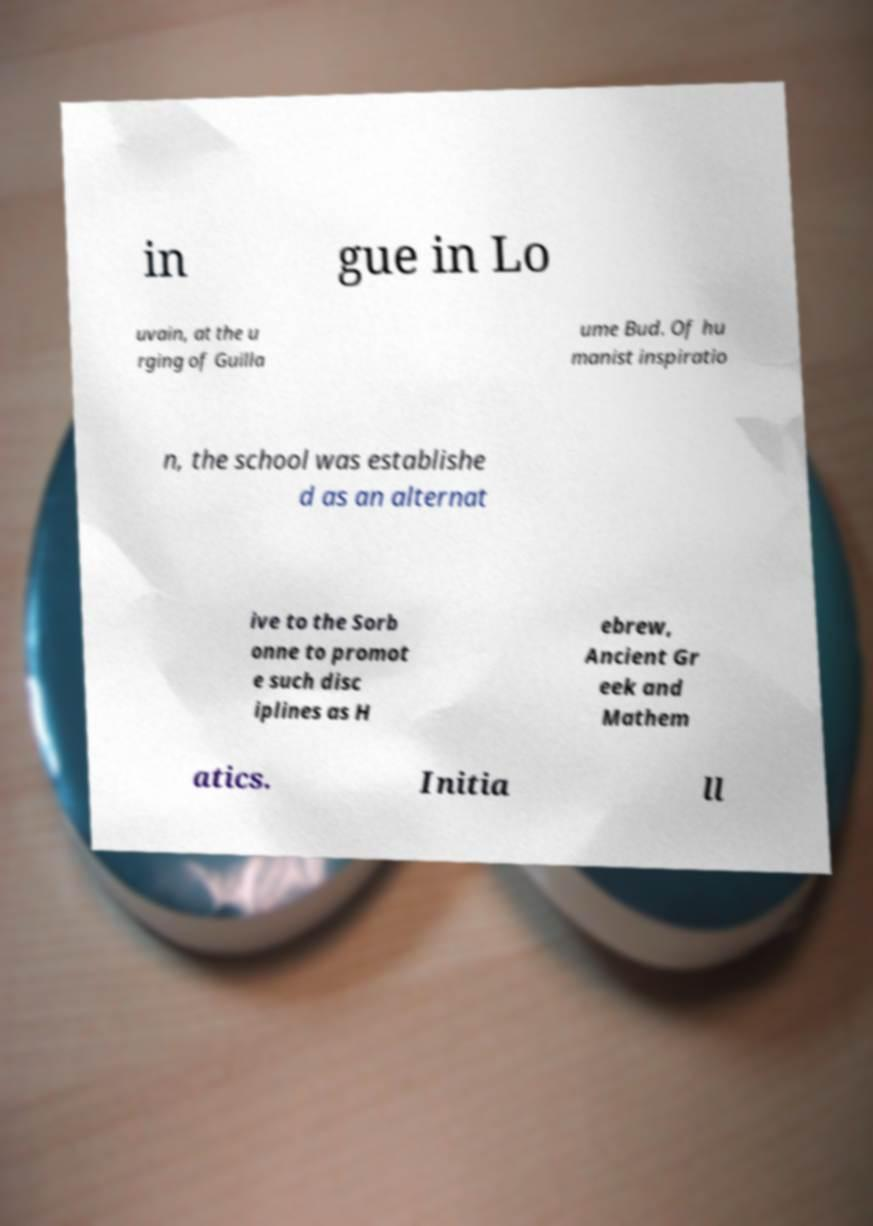Can you accurately transcribe the text from the provided image for me? in gue in Lo uvain, at the u rging of Guilla ume Bud. Of hu manist inspiratio n, the school was establishe d as an alternat ive to the Sorb onne to promot e such disc iplines as H ebrew, Ancient Gr eek and Mathem atics. Initia ll 